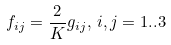<formula> <loc_0><loc_0><loc_500><loc_500>f _ { i j } = \frac { 2 } { K } g _ { i j } , \, i , j = 1 . . 3</formula> 